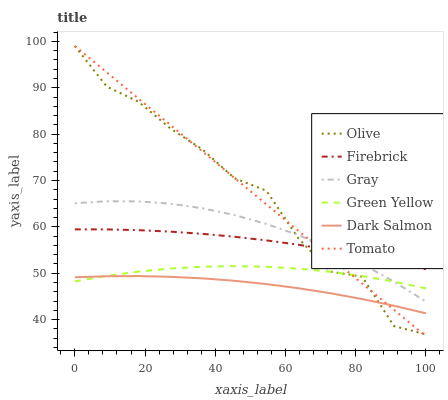Does Dark Salmon have the minimum area under the curve?
Answer yes or no. Yes. Does Tomato have the maximum area under the curve?
Answer yes or no. Yes. Does Gray have the minimum area under the curve?
Answer yes or no. No. Does Gray have the maximum area under the curve?
Answer yes or no. No. Is Tomato the smoothest?
Answer yes or no. Yes. Is Olive the roughest?
Answer yes or no. Yes. Is Gray the smoothest?
Answer yes or no. No. Is Gray the roughest?
Answer yes or no. No. Does Tomato have the lowest value?
Answer yes or no. Yes. Does Gray have the lowest value?
Answer yes or no. No. Does Olive have the highest value?
Answer yes or no. Yes. Does Gray have the highest value?
Answer yes or no. No. Is Green Yellow less than Firebrick?
Answer yes or no. Yes. Is Gray greater than Dark Salmon?
Answer yes or no. Yes. Does Tomato intersect Green Yellow?
Answer yes or no. Yes. Is Tomato less than Green Yellow?
Answer yes or no. No. Is Tomato greater than Green Yellow?
Answer yes or no. No. Does Green Yellow intersect Firebrick?
Answer yes or no. No. 